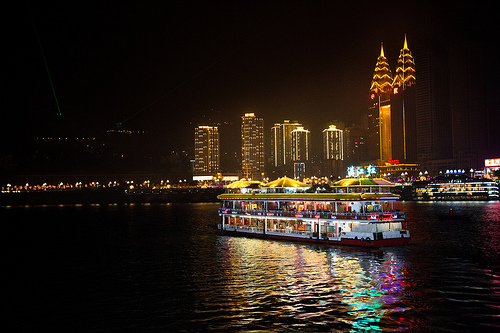If you could rename this city, what would you call it and why? I would call this city 'Lumina Harbor.' The name reflects the city's radiant and bustling nightscape, with its beautifully illuminated buildings alongside a lively waterfront, emphasizing its charm and vibrancy. 